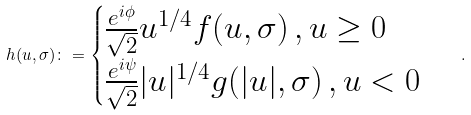Convert formula to latex. <formula><loc_0><loc_0><loc_500><loc_500>h ( u , \sigma ) \colon = \begin{cases} \frac { e ^ { i \phi } } { \sqrt { 2 } } u ^ { 1 / 4 } f ( u , \sigma ) \, , u \geq 0 \\ \frac { e ^ { i \psi } } { \sqrt { 2 } } | u | ^ { 1 / 4 } g ( | u | , \sigma ) \, , u < 0 \end{cases} \, .</formula> 